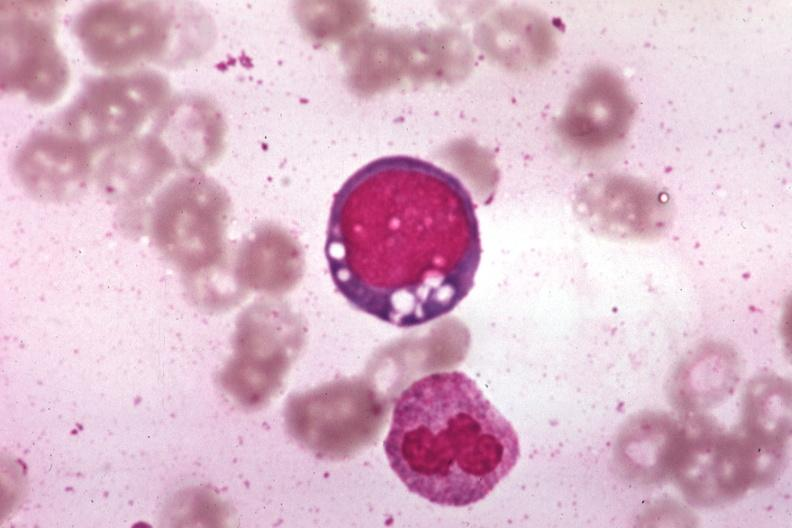what is wrights vacuolated?
Answer the question using a single word or phrase. Erythroblast source unknown 